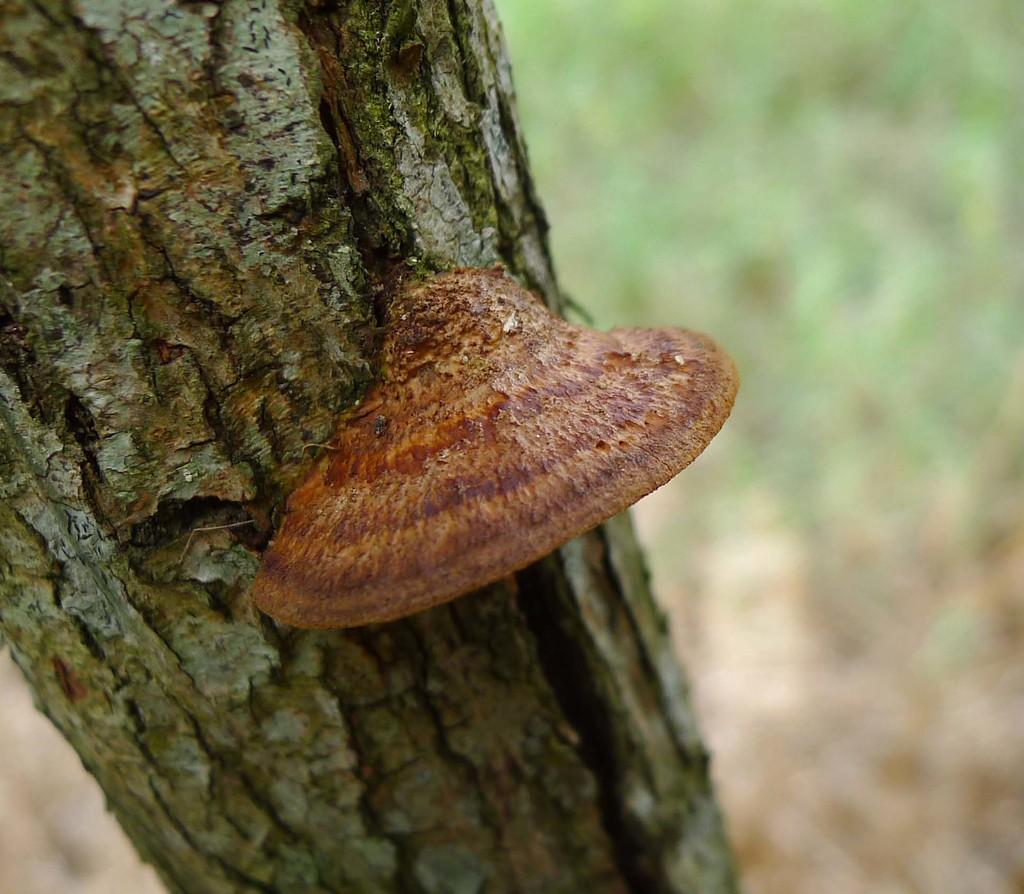What is the main subject of the image? The main subject of the image is a tree trunk. Is there anything attached to the tree trunk? Yes, there is a brown-colored object on the tree trunk. How would you describe the overall quality of the image? The image is slightly blurry in the background. Can you tell me how many pets are visible in the image? There are no pets present in the image; it features a tree trunk with a brown-colored object on it. What type of town can be seen in the background of the image? There is no town visible in the image; it is a close-up of a tree trunk with a blurry background. 